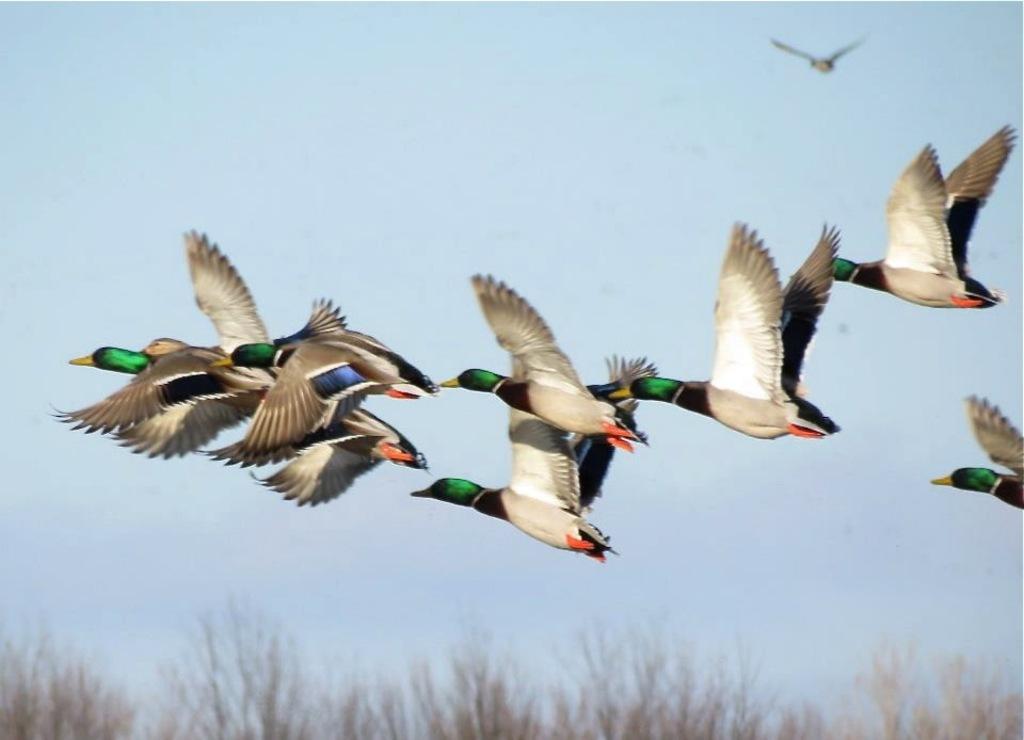In one or two sentences, can you explain what this image depicts? In the image there are birds flying in the sky. At the bottom of the image there is grass. In the background there is sky. 